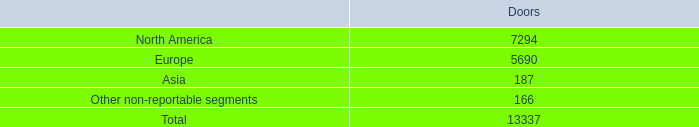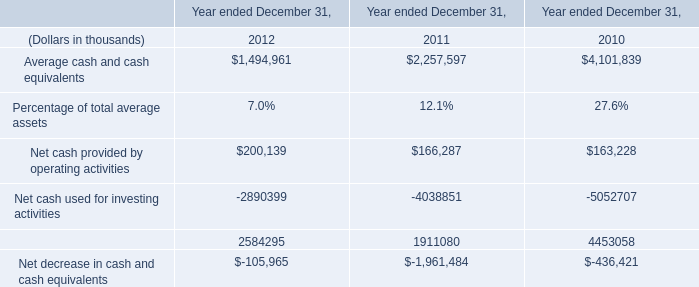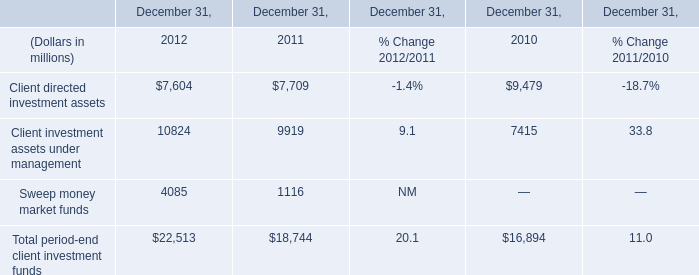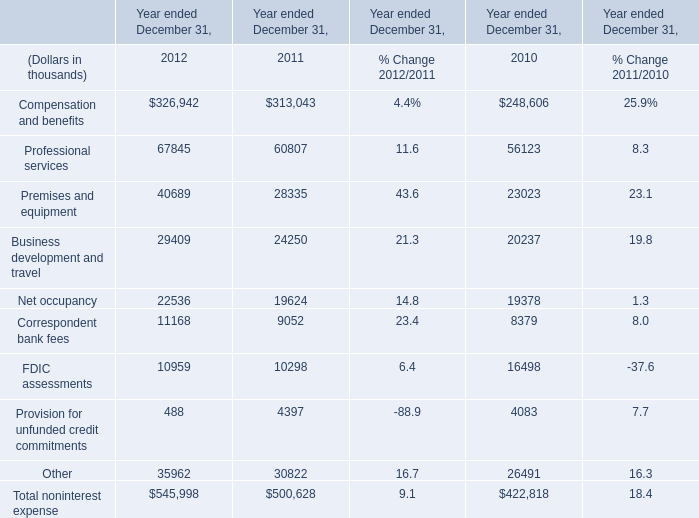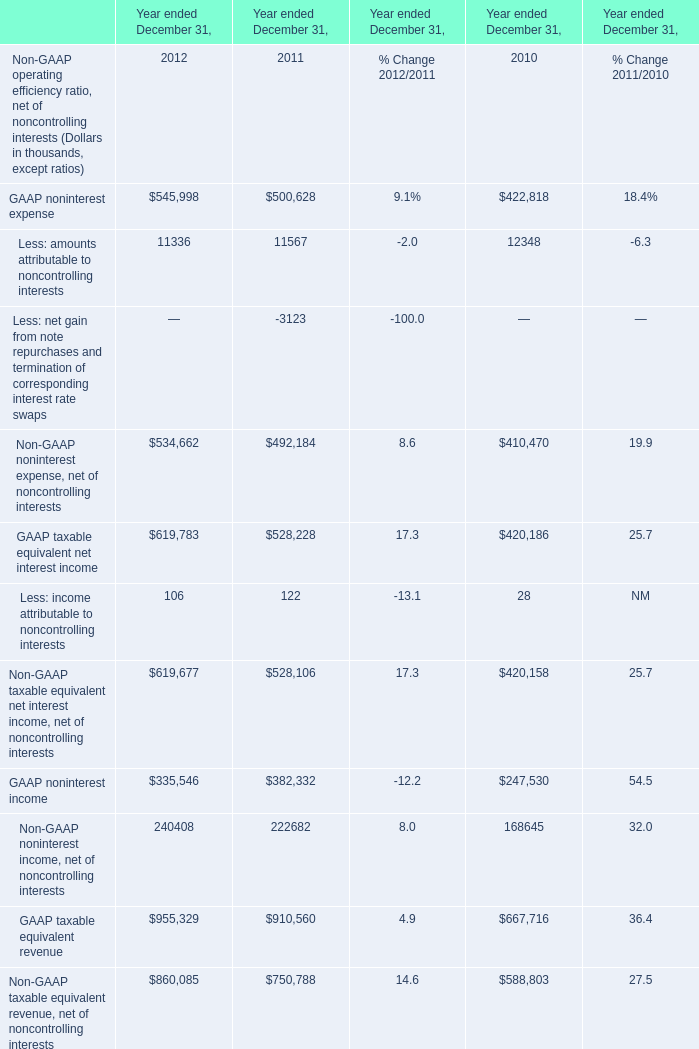what's the total amount of North America of Doors, and Business development and travel of Year ended December 31, 2011 ? 
Computations: (7294.0 + 24250.0)
Answer: 31544.0. 